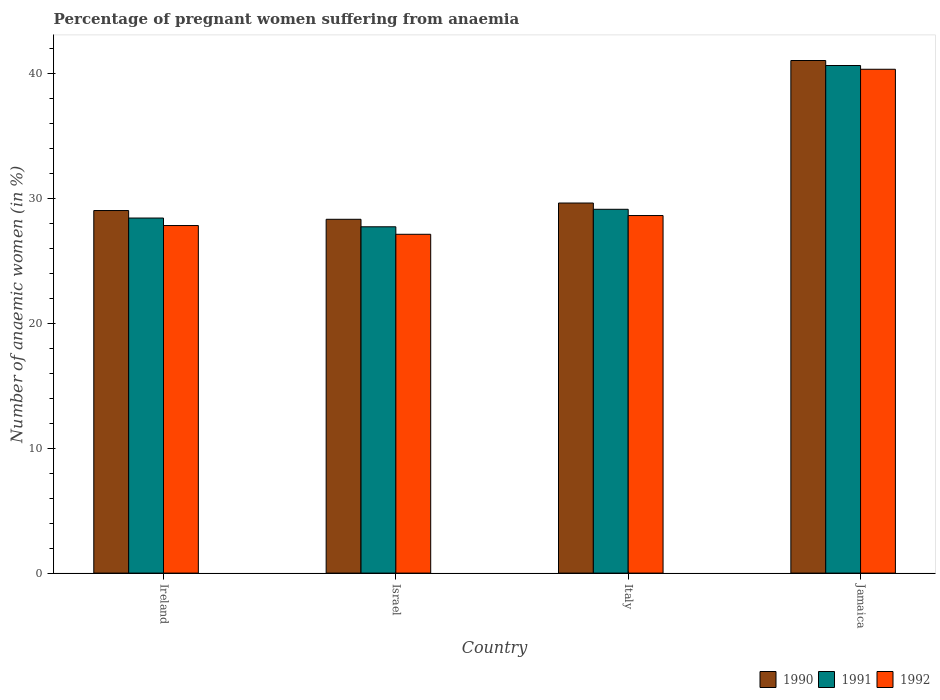How many bars are there on the 2nd tick from the left?
Give a very brief answer. 3. What is the label of the 1st group of bars from the left?
Your answer should be very brief. Ireland. In how many cases, is the number of bars for a given country not equal to the number of legend labels?
Your answer should be compact. 0. What is the number of anaemic women in 1991 in Jamaica?
Keep it short and to the point. 40.6. Across all countries, what is the maximum number of anaemic women in 1992?
Provide a succinct answer. 40.3. Across all countries, what is the minimum number of anaemic women in 1992?
Offer a terse response. 27.1. In which country was the number of anaemic women in 1991 maximum?
Offer a very short reply. Jamaica. What is the total number of anaemic women in 1992 in the graph?
Offer a very short reply. 123.8. What is the difference between the number of anaemic women in 1992 in Ireland and that in Jamaica?
Ensure brevity in your answer.  -12.5. What is the difference between the number of anaemic women in 1992 in Jamaica and the number of anaemic women in 1990 in Italy?
Your answer should be compact. 10.7. What is the average number of anaemic women in 1992 per country?
Make the answer very short. 30.95. What is the difference between the number of anaemic women of/in 1992 and number of anaemic women of/in 1990 in Ireland?
Make the answer very short. -1.2. What is the ratio of the number of anaemic women in 1992 in Israel to that in Jamaica?
Offer a terse response. 0.67. What is the difference between the highest and the second highest number of anaemic women in 1991?
Your answer should be very brief. 12.2. What is the difference between the highest and the lowest number of anaemic women in 1991?
Your answer should be very brief. 12.9. Is the sum of the number of anaemic women in 1991 in Ireland and Jamaica greater than the maximum number of anaemic women in 1992 across all countries?
Offer a very short reply. Yes. What does the 1st bar from the right in Jamaica represents?
Ensure brevity in your answer.  1992. Are all the bars in the graph horizontal?
Your answer should be very brief. No. How many countries are there in the graph?
Make the answer very short. 4. What is the difference between two consecutive major ticks on the Y-axis?
Offer a terse response. 10. Are the values on the major ticks of Y-axis written in scientific E-notation?
Provide a short and direct response. No. Does the graph contain any zero values?
Your answer should be compact. No. Where does the legend appear in the graph?
Provide a succinct answer. Bottom right. How many legend labels are there?
Offer a terse response. 3. What is the title of the graph?
Make the answer very short. Percentage of pregnant women suffering from anaemia. Does "1999" appear as one of the legend labels in the graph?
Offer a very short reply. No. What is the label or title of the X-axis?
Keep it short and to the point. Country. What is the label or title of the Y-axis?
Provide a short and direct response. Number of anaemic women (in %). What is the Number of anaemic women (in %) in 1991 in Ireland?
Offer a terse response. 28.4. What is the Number of anaemic women (in %) in 1992 in Ireland?
Ensure brevity in your answer.  27.8. What is the Number of anaemic women (in %) of 1990 in Israel?
Provide a short and direct response. 28.3. What is the Number of anaemic women (in %) in 1991 in Israel?
Offer a very short reply. 27.7. What is the Number of anaemic women (in %) in 1992 in Israel?
Provide a short and direct response. 27.1. What is the Number of anaemic women (in %) of 1990 in Italy?
Offer a very short reply. 29.6. What is the Number of anaemic women (in %) in 1991 in Italy?
Make the answer very short. 29.1. What is the Number of anaemic women (in %) in 1992 in Italy?
Provide a succinct answer. 28.6. What is the Number of anaemic women (in %) in 1991 in Jamaica?
Give a very brief answer. 40.6. What is the Number of anaemic women (in %) in 1992 in Jamaica?
Your answer should be compact. 40.3. Across all countries, what is the maximum Number of anaemic women (in %) of 1991?
Your answer should be very brief. 40.6. Across all countries, what is the maximum Number of anaemic women (in %) in 1992?
Keep it short and to the point. 40.3. Across all countries, what is the minimum Number of anaemic women (in %) in 1990?
Make the answer very short. 28.3. Across all countries, what is the minimum Number of anaemic women (in %) of 1991?
Your answer should be very brief. 27.7. Across all countries, what is the minimum Number of anaemic women (in %) of 1992?
Offer a terse response. 27.1. What is the total Number of anaemic women (in %) in 1990 in the graph?
Give a very brief answer. 127.9. What is the total Number of anaemic women (in %) in 1991 in the graph?
Provide a short and direct response. 125.8. What is the total Number of anaemic women (in %) in 1992 in the graph?
Keep it short and to the point. 123.8. What is the difference between the Number of anaemic women (in %) of 1992 in Ireland and that in Israel?
Offer a terse response. 0.7. What is the difference between the Number of anaemic women (in %) of 1992 in Ireland and that in Italy?
Keep it short and to the point. -0.8. What is the difference between the Number of anaemic women (in %) in 1992 in Ireland and that in Jamaica?
Offer a terse response. -12.5. What is the difference between the Number of anaemic women (in %) in 1990 in Italy and that in Jamaica?
Your answer should be compact. -11.4. What is the difference between the Number of anaemic women (in %) in 1992 in Italy and that in Jamaica?
Provide a short and direct response. -11.7. What is the difference between the Number of anaemic women (in %) in 1990 in Ireland and the Number of anaemic women (in %) in 1992 in Israel?
Your response must be concise. 1.9. What is the difference between the Number of anaemic women (in %) of 1990 in Ireland and the Number of anaemic women (in %) of 1991 in Italy?
Offer a very short reply. -0.1. What is the difference between the Number of anaemic women (in %) in 1990 in Ireland and the Number of anaemic women (in %) in 1992 in Italy?
Make the answer very short. 0.4. What is the difference between the Number of anaemic women (in %) in 1991 in Ireland and the Number of anaemic women (in %) in 1992 in Italy?
Your answer should be very brief. -0.2. What is the difference between the Number of anaemic women (in %) in 1990 in Ireland and the Number of anaemic women (in %) in 1991 in Jamaica?
Your answer should be very brief. -11.6. What is the difference between the Number of anaemic women (in %) of 1990 in Ireland and the Number of anaemic women (in %) of 1992 in Jamaica?
Your answer should be compact. -11.3. What is the difference between the Number of anaemic women (in %) of 1990 in Israel and the Number of anaemic women (in %) of 1991 in Italy?
Provide a succinct answer. -0.8. What is the difference between the Number of anaemic women (in %) in 1991 in Israel and the Number of anaemic women (in %) in 1992 in Italy?
Your answer should be compact. -0.9. What is the difference between the Number of anaemic women (in %) of 1990 in Israel and the Number of anaemic women (in %) of 1991 in Jamaica?
Offer a terse response. -12.3. What is the difference between the Number of anaemic women (in %) in 1990 in Israel and the Number of anaemic women (in %) in 1992 in Jamaica?
Your response must be concise. -12. What is the difference between the Number of anaemic women (in %) of 1991 in Israel and the Number of anaemic women (in %) of 1992 in Jamaica?
Your answer should be very brief. -12.6. What is the difference between the Number of anaemic women (in %) of 1991 in Italy and the Number of anaemic women (in %) of 1992 in Jamaica?
Offer a terse response. -11.2. What is the average Number of anaemic women (in %) of 1990 per country?
Provide a short and direct response. 31.98. What is the average Number of anaemic women (in %) in 1991 per country?
Give a very brief answer. 31.45. What is the average Number of anaemic women (in %) in 1992 per country?
Make the answer very short. 30.95. What is the difference between the Number of anaemic women (in %) in 1990 and Number of anaemic women (in %) in 1992 in Ireland?
Your answer should be very brief. 1.2. What is the difference between the Number of anaemic women (in %) of 1991 and Number of anaemic women (in %) of 1992 in Ireland?
Your response must be concise. 0.6. What is the difference between the Number of anaemic women (in %) of 1990 and Number of anaemic women (in %) of 1991 in Israel?
Provide a succinct answer. 0.6. What is the difference between the Number of anaemic women (in %) of 1991 and Number of anaemic women (in %) of 1992 in Israel?
Provide a short and direct response. 0.6. What is the difference between the Number of anaemic women (in %) of 1990 and Number of anaemic women (in %) of 1991 in Italy?
Provide a succinct answer. 0.5. What is the difference between the Number of anaemic women (in %) of 1990 and Number of anaemic women (in %) of 1992 in Italy?
Offer a very short reply. 1. What is the difference between the Number of anaemic women (in %) of 1991 and Number of anaemic women (in %) of 1992 in Italy?
Offer a terse response. 0.5. What is the difference between the Number of anaemic women (in %) of 1990 and Number of anaemic women (in %) of 1991 in Jamaica?
Make the answer very short. 0.4. What is the difference between the Number of anaemic women (in %) of 1991 and Number of anaemic women (in %) of 1992 in Jamaica?
Offer a very short reply. 0.3. What is the ratio of the Number of anaemic women (in %) in 1990 in Ireland to that in Israel?
Your answer should be very brief. 1.02. What is the ratio of the Number of anaemic women (in %) in 1991 in Ireland to that in Israel?
Ensure brevity in your answer.  1.03. What is the ratio of the Number of anaemic women (in %) in 1992 in Ireland to that in Israel?
Offer a very short reply. 1.03. What is the ratio of the Number of anaemic women (in %) of 1990 in Ireland to that in Italy?
Offer a terse response. 0.98. What is the ratio of the Number of anaemic women (in %) of 1991 in Ireland to that in Italy?
Make the answer very short. 0.98. What is the ratio of the Number of anaemic women (in %) of 1992 in Ireland to that in Italy?
Your response must be concise. 0.97. What is the ratio of the Number of anaemic women (in %) of 1990 in Ireland to that in Jamaica?
Your answer should be compact. 0.71. What is the ratio of the Number of anaemic women (in %) in 1991 in Ireland to that in Jamaica?
Offer a very short reply. 0.7. What is the ratio of the Number of anaemic women (in %) of 1992 in Ireland to that in Jamaica?
Provide a short and direct response. 0.69. What is the ratio of the Number of anaemic women (in %) in 1990 in Israel to that in Italy?
Your answer should be compact. 0.96. What is the ratio of the Number of anaemic women (in %) in 1991 in Israel to that in Italy?
Offer a terse response. 0.95. What is the ratio of the Number of anaemic women (in %) of 1992 in Israel to that in Italy?
Ensure brevity in your answer.  0.95. What is the ratio of the Number of anaemic women (in %) of 1990 in Israel to that in Jamaica?
Provide a short and direct response. 0.69. What is the ratio of the Number of anaemic women (in %) of 1991 in Israel to that in Jamaica?
Your response must be concise. 0.68. What is the ratio of the Number of anaemic women (in %) in 1992 in Israel to that in Jamaica?
Your answer should be compact. 0.67. What is the ratio of the Number of anaemic women (in %) in 1990 in Italy to that in Jamaica?
Make the answer very short. 0.72. What is the ratio of the Number of anaemic women (in %) in 1991 in Italy to that in Jamaica?
Keep it short and to the point. 0.72. What is the ratio of the Number of anaemic women (in %) in 1992 in Italy to that in Jamaica?
Your answer should be compact. 0.71. What is the difference between the highest and the second highest Number of anaemic women (in %) in 1992?
Provide a succinct answer. 11.7. What is the difference between the highest and the lowest Number of anaemic women (in %) of 1991?
Provide a short and direct response. 12.9. What is the difference between the highest and the lowest Number of anaemic women (in %) of 1992?
Your answer should be compact. 13.2. 